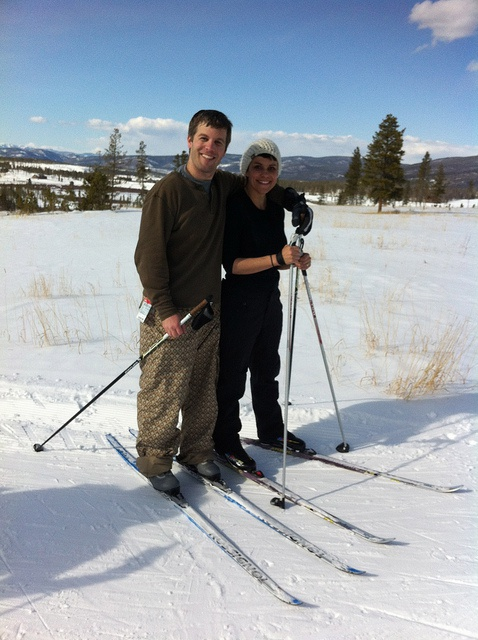Describe the objects in this image and their specific colors. I can see people in gray, black, and maroon tones, people in gray, black, maroon, and lightgray tones, skis in gray, lightgray, and darkgray tones, and skis in gray, darkgray, lightgray, and black tones in this image. 